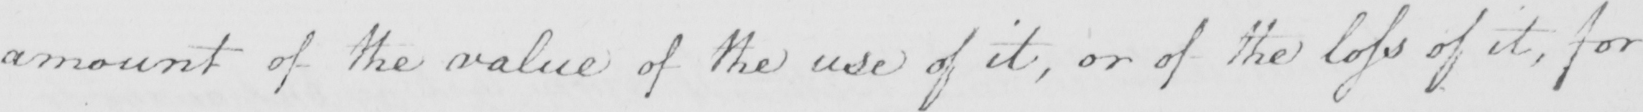Please transcribe the handwritten text in this image. amount of the value of the use of it , or of the loss of it , for 